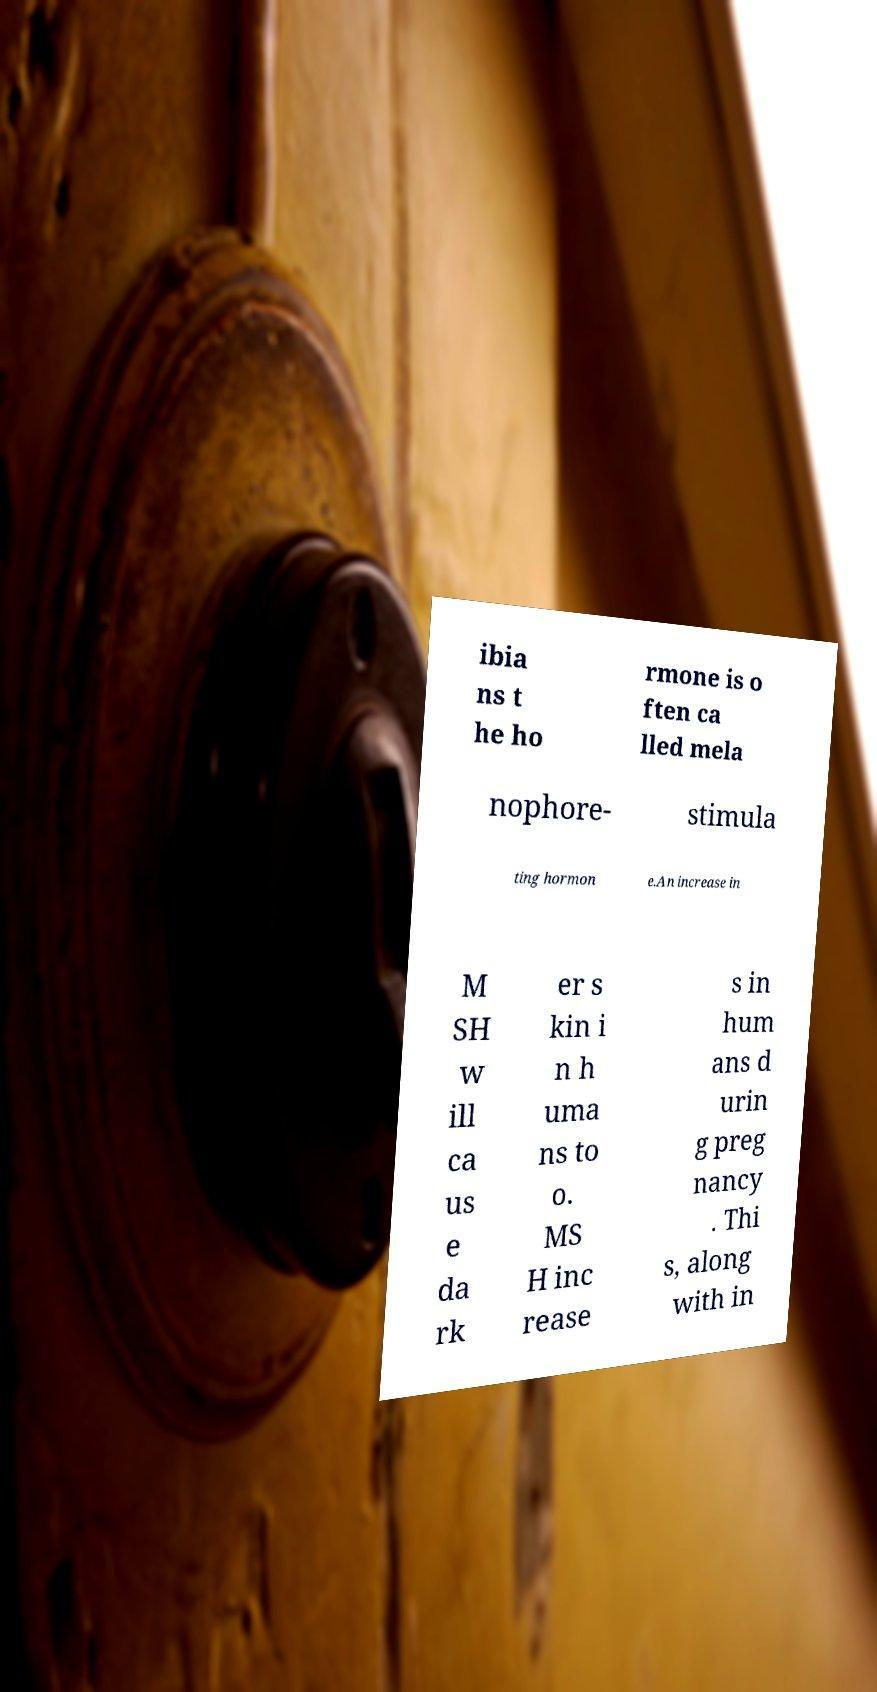I need the written content from this picture converted into text. Can you do that? ibia ns t he ho rmone is o ften ca lled mela nophore- stimula ting hormon e.An increase in M SH w ill ca us e da rk er s kin i n h uma ns to o. MS H inc rease s in hum ans d urin g preg nancy . Thi s, along with in 